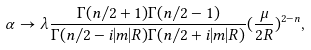<formula> <loc_0><loc_0><loc_500><loc_500>\alpha \to \lambda \frac { \Gamma ( n / 2 + 1 ) \Gamma ( n / 2 - 1 ) } { \Gamma ( n / 2 - i | m | R ) \Gamma ( n / 2 + i | m | R ) } ( \frac { \mu } { 2 R } ) ^ { 2 - n } ,</formula> 